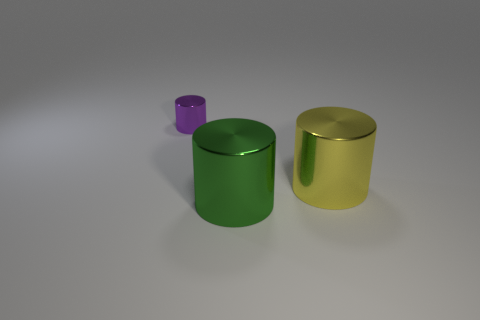Are there more small purple metallic cylinders than large metallic cylinders?
Provide a short and direct response. No. How many things are metal cylinders on the left side of the big yellow thing or tiny gray blocks?
Your answer should be very brief. 2. Is there a yellow metal cylinder that has the same size as the green shiny cylinder?
Offer a very short reply. Yes. Are there fewer green shiny cylinders than gray matte spheres?
Your response must be concise. No. How many cylinders are metal things or tiny objects?
Provide a short and direct response. 3. What size is the metal cylinder that is both behind the green metal thing and on the left side of the large yellow thing?
Give a very brief answer. Small. Are there fewer tiny cylinders that are right of the yellow cylinder than big yellow metallic things?
Provide a short and direct response. Yes. Are the green cylinder and the large yellow object made of the same material?
Offer a terse response. Yes. What number of things are either brown spheres or green shiny cylinders?
Provide a short and direct response. 1. How many other things have the same material as the green thing?
Make the answer very short. 2. 